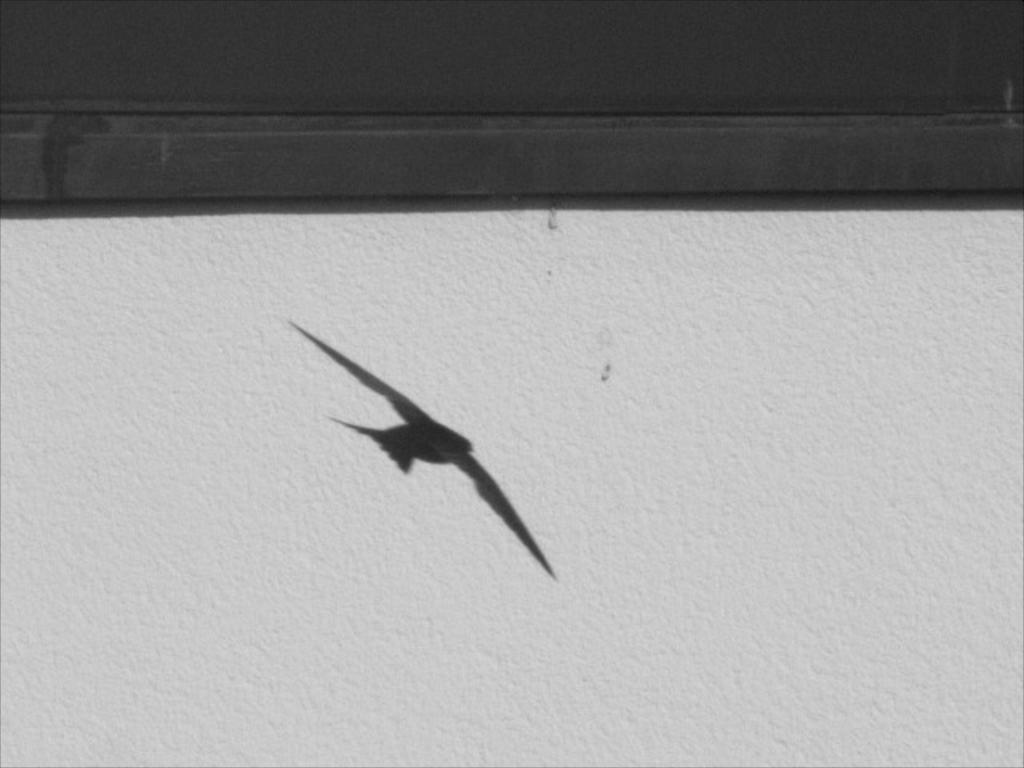What is present on the wall in the image? There is a painting of a bird on the wall. Can you describe the painting on the wall? The painting on the wall features a bird. What is the skin condition of the bird in the painting? There is no information about the bird's skin condition in the image, as it is a painting. How many steps are required to reach the bird in the painting? The bird is a part of a painting, so it is not physically present and cannot be reached by taking steps. 